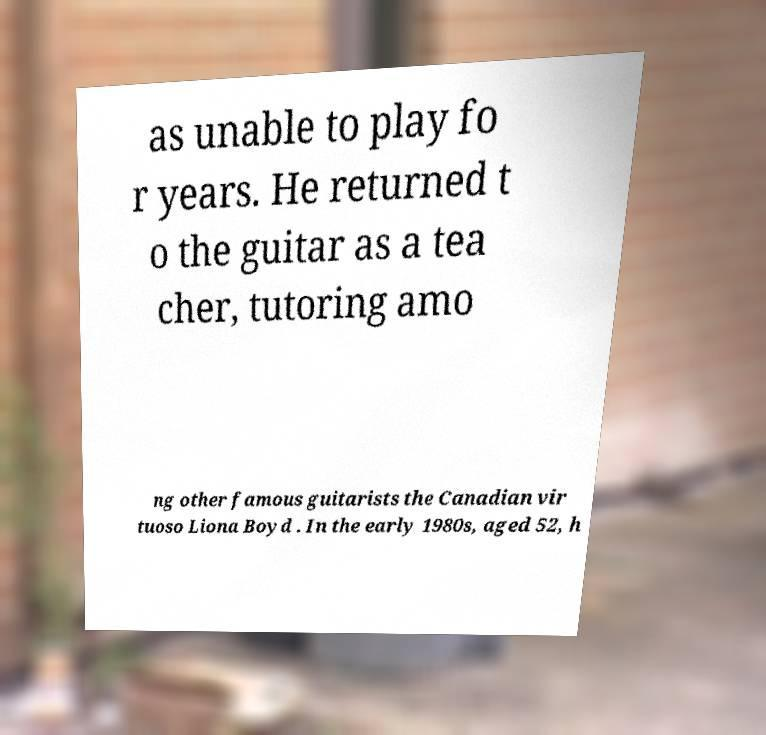What messages or text are displayed in this image? I need them in a readable, typed format. as unable to play fo r years. He returned t o the guitar as a tea cher, tutoring amo ng other famous guitarists the Canadian vir tuoso Liona Boyd . In the early 1980s, aged 52, h 